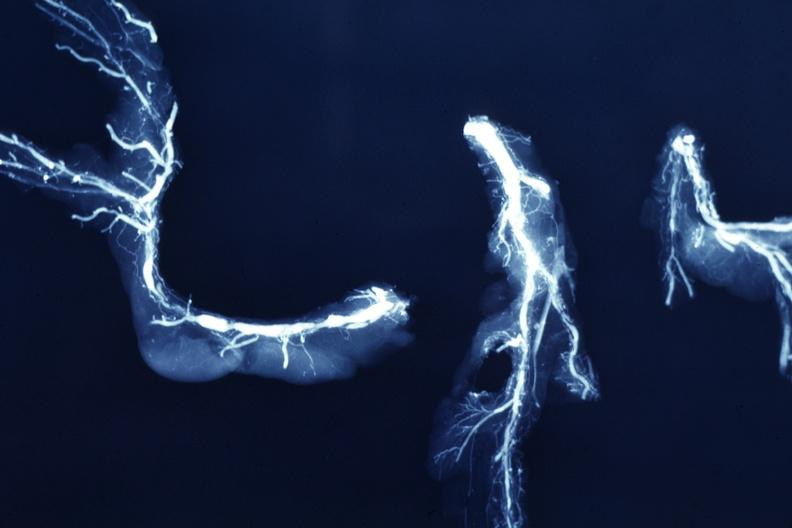s amyloidosis present?
Answer the question using a single word or phrase. No 